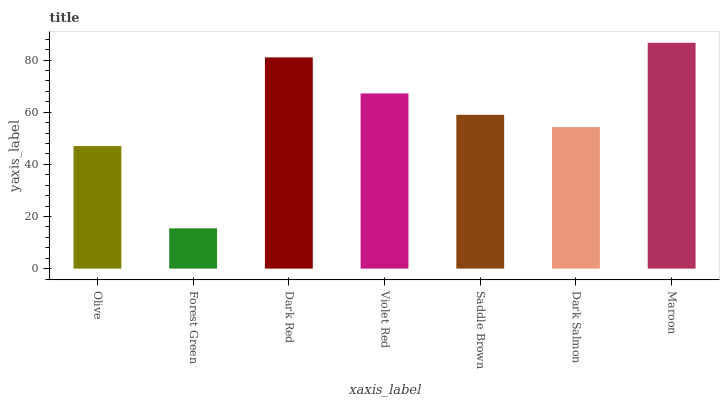Is Forest Green the minimum?
Answer yes or no. Yes. Is Maroon the maximum?
Answer yes or no. Yes. Is Dark Red the minimum?
Answer yes or no. No. Is Dark Red the maximum?
Answer yes or no. No. Is Dark Red greater than Forest Green?
Answer yes or no. Yes. Is Forest Green less than Dark Red?
Answer yes or no. Yes. Is Forest Green greater than Dark Red?
Answer yes or no. No. Is Dark Red less than Forest Green?
Answer yes or no. No. Is Saddle Brown the high median?
Answer yes or no. Yes. Is Saddle Brown the low median?
Answer yes or no. Yes. Is Forest Green the high median?
Answer yes or no. No. Is Olive the low median?
Answer yes or no. No. 